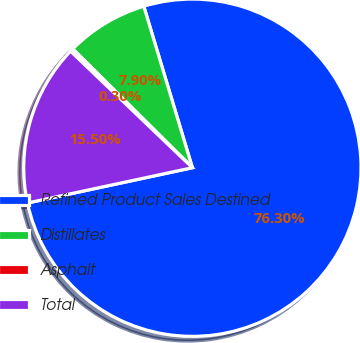Convert chart. <chart><loc_0><loc_0><loc_500><loc_500><pie_chart><fcel>Refined Product Sales Destined<fcel>Distillates<fcel>Asphalt<fcel>Total<nl><fcel>76.29%<fcel>7.9%<fcel>0.3%<fcel>15.5%<nl></chart> 